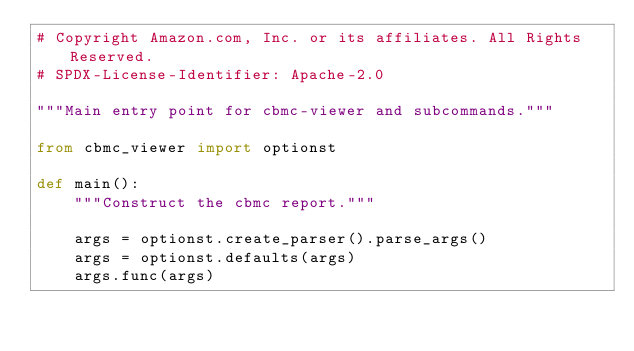<code> <loc_0><loc_0><loc_500><loc_500><_Python_># Copyright Amazon.com, Inc. or its affiliates. All Rights Reserved.
# SPDX-License-Identifier: Apache-2.0

"""Main entry point for cbmc-viewer and subcommands."""

from cbmc_viewer import optionst

def main():
    """Construct the cbmc report."""

    args = optionst.create_parser().parse_args()
    args = optionst.defaults(args)
    args.func(args)
</code> 